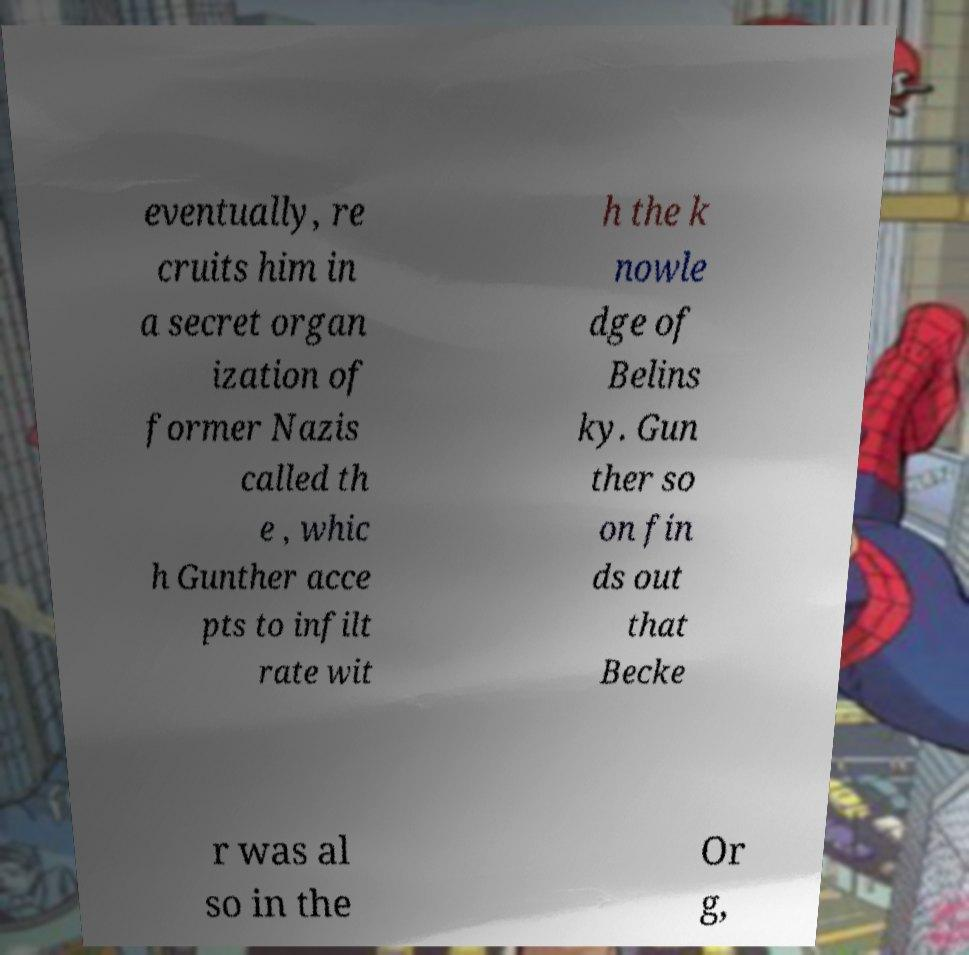Could you assist in decoding the text presented in this image and type it out clearly? eventually, re cruits him in a secret organ ization of former Nazis called th e , whic h Gunther acce pts to infilt rate wit h the k nowle dge of Belins ky. Gun ther so on fin ds out that Becke r was al so in the Or g, 